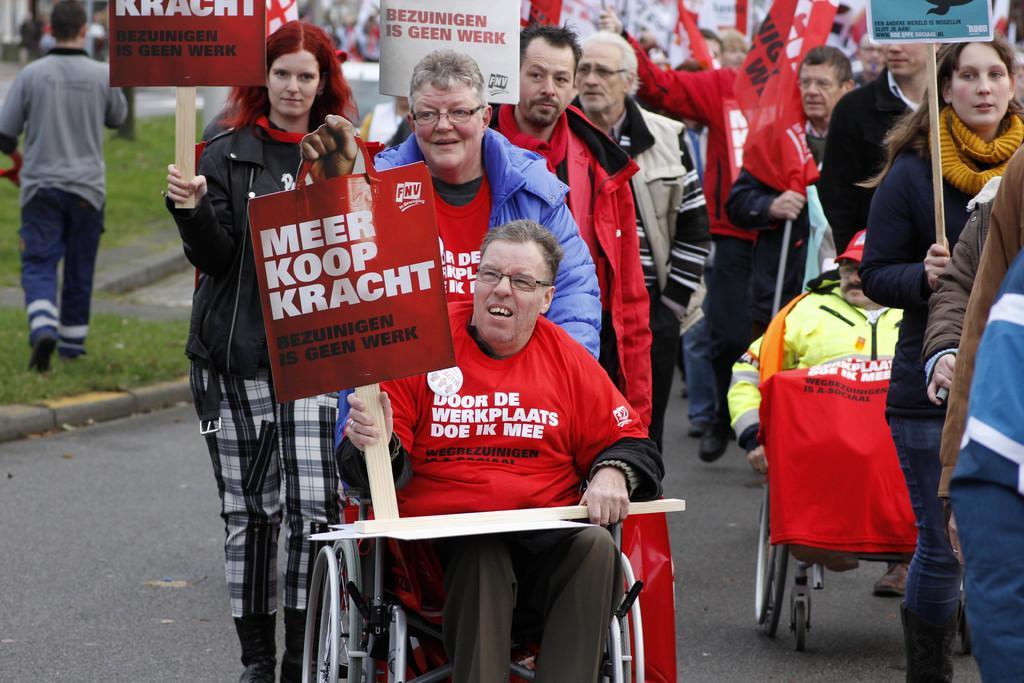Please provide a concise description of this image. In this image in front there is a person sitting on the chair holding the pluck card. Behind him there are few other people standing on the road. At the left side of the image there is grass on the surface. 